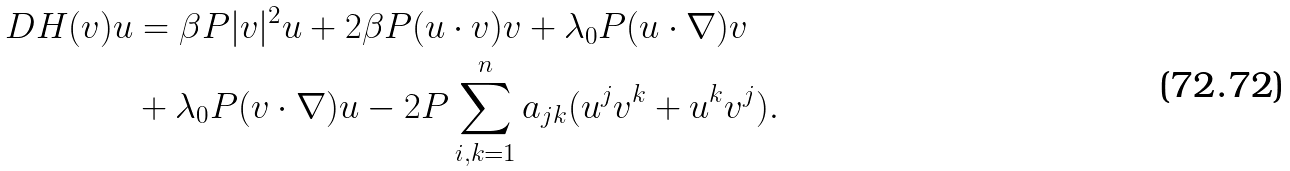<formula> <loc_0><loc_0><loc_500><loc_500>D H ( v ) u & = \beta P | v | ^ { 2 } u + 2 \beta P ( u \cdot v ) v + \lambda _ { 0 } P ( u \cdot \nabla ) v \\ & + \lambda _ { 0 } P ( v \cdot \nabla ) u - 2 P \sum _ { i , k = 1 } ^ { n } a _ { j k } ( u ^ { j } v ^ { k } + u ^ { k } v ^ { j } ) .</formula> 